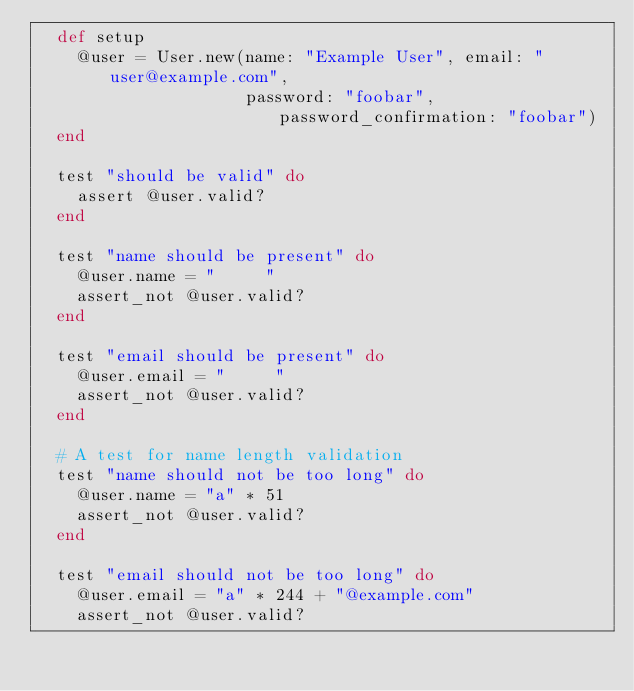<code> <loc_0><loc_0><loc_500><loc_500><_Ruby_>  def setup
    @user = User.new(name: "Example User", email: "user@example.com",
                     password: "foobar", password_confirmation: "foobar")
  end

  test "should be valid" do
    assert @user.valid?
  end

  test "name should be present" do
    @user.name = "     "
    assert_not @user.valid?
  end

  test "email should be present" do
    @user.email = "     "
    assert_not @user.valid?
  end

  # A test for name length validation
  test "name should not be too long" do
    @user.name = "a" * 51
    assert_not @user.valid?
  end

  test "email should not be too long" do
    @user.email = "a" * 244 + "@example.com"
    assert_not @user.valid?</code> 